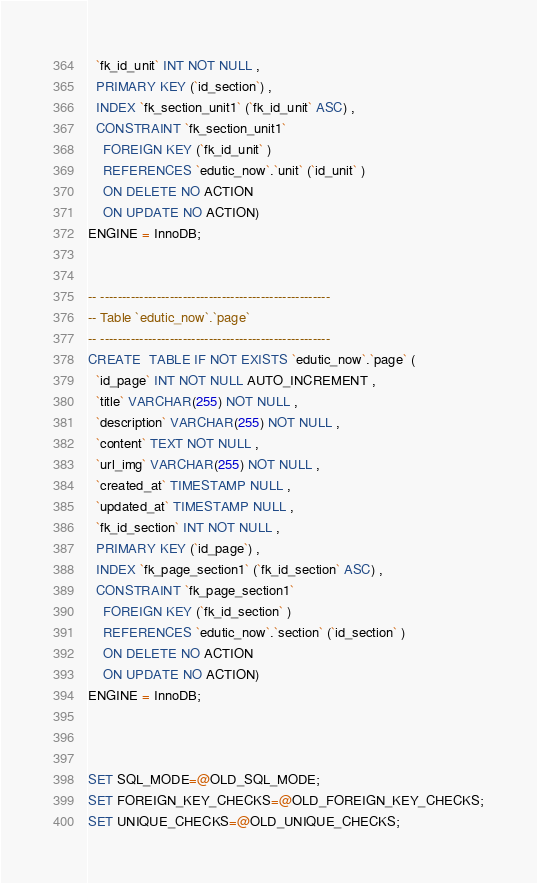Convert code to text. <code><loc_0><loc_0><loc_500><loc_500><_SQL_>  `fk_id_unit` INT NOT NULL ,
  PRIMARY KEY (`id_section`) ,
  INDEX `fk_section_unit1` (`fk_id_unit` ASC) ,
  CONSTRAINT `fk_section_unit1`
    FOREIGN KEY (`fk_id_unit` )
    REFERENCES `edutic_now`.`unit` (`id_unit` )
    ON DELETE NO ACTION
    ON UPDATE NO ACTION)
ENGINE = InnoDB;


-- -----------------------------------------------------
-- Table `edutic_now`.`page`
-- -----------------------------------------------------
CREATE  TABLE IF NOT EXISTS `edutic_now`.`page` (
  `id_page` INT NOT NULL AUTO_INCREMENT ,
  `title` VARCHAR(255) NOT NULL ,
  `description` VARCHAR(255) NOT NULL ,
  `content` TEXT NOT NULL ,
  `url_img` VARCHAR(255) NOT NULL ,
  `created_at` TIMESTAMP NULL ,
  `updated_at` TIMESTAMP NULL ,
  `fk_id_section` INT NOT NULL ,
  PRIMARY KEY (`id_page`) ,
  INDEX `fk_page_section1` (`fk_id_section` ASC) ,
  CONSTRAINT `fk_page_section1`
    FOREIGN KEY (`fk_id_section` )
    REFERENCES `edutic_now`.`section` (`id_section` )
    ON DELETE NO ACTION
    ON UPDATE NO ACTION)
ENGINE = InnoDB;



SET SQL_MODE=@OLD_SQL_MODE;
SET FOREIGN_KEY_CHECKS=@OLD_FOREIGN_KEY_CHECKS;
SET UNIQUE_CHECKS=@OLD_UNIQUE_CHECKS;
</code> 